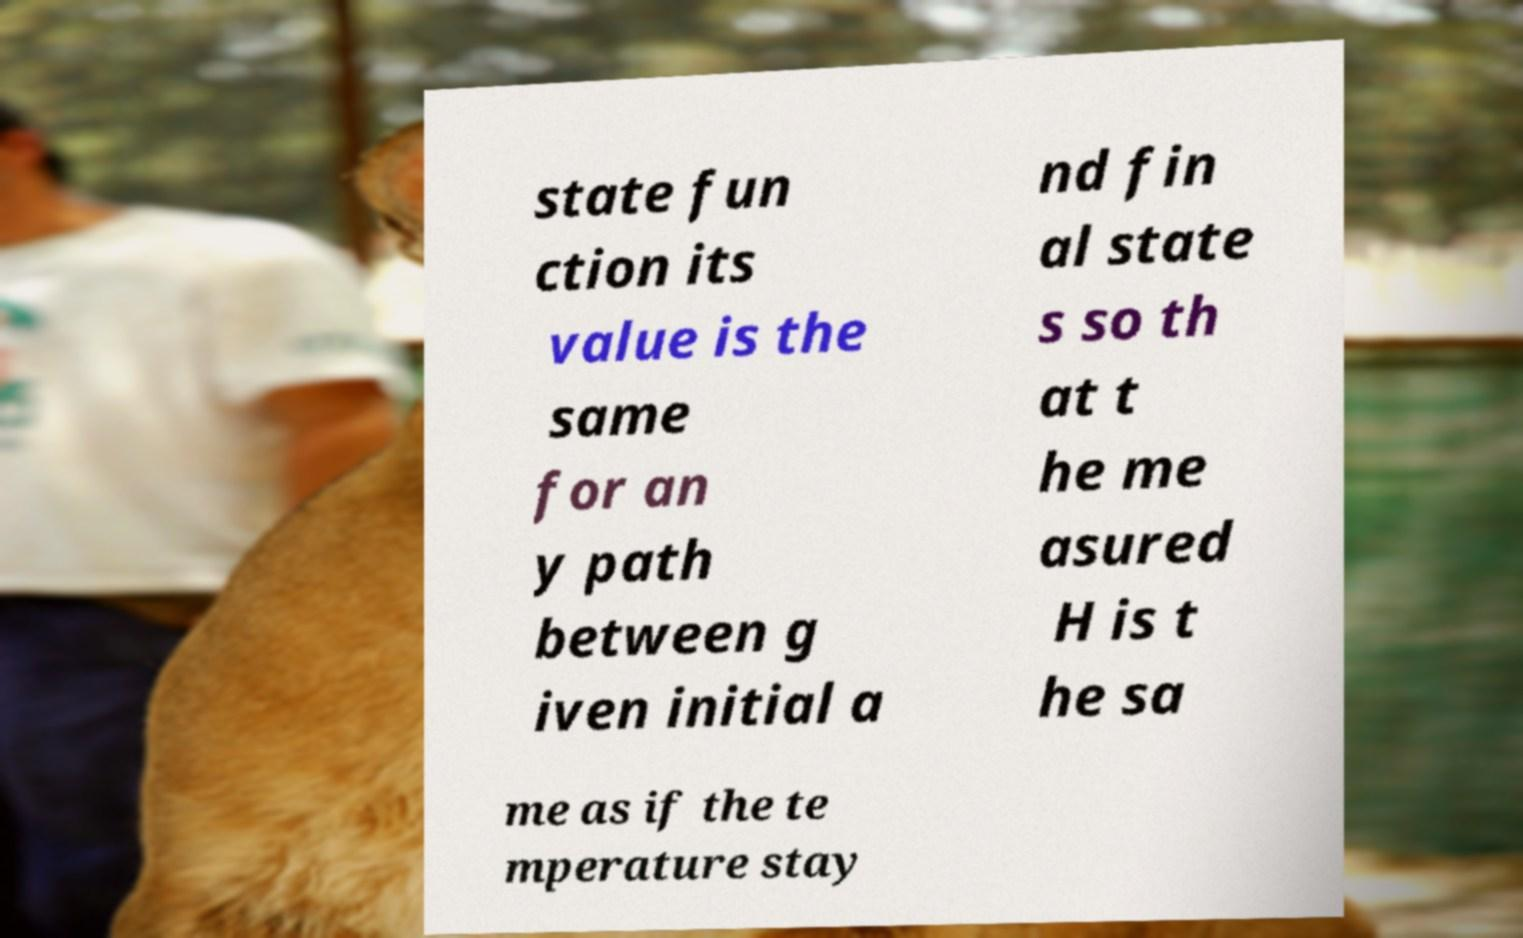Could you assist in decoding the text presented in this image and type it out clearly? state fun ction its value is the same for an y path between g iven initial a nd fin al state s so th at t he me asured H is t he sa me as if the te mperature stay 